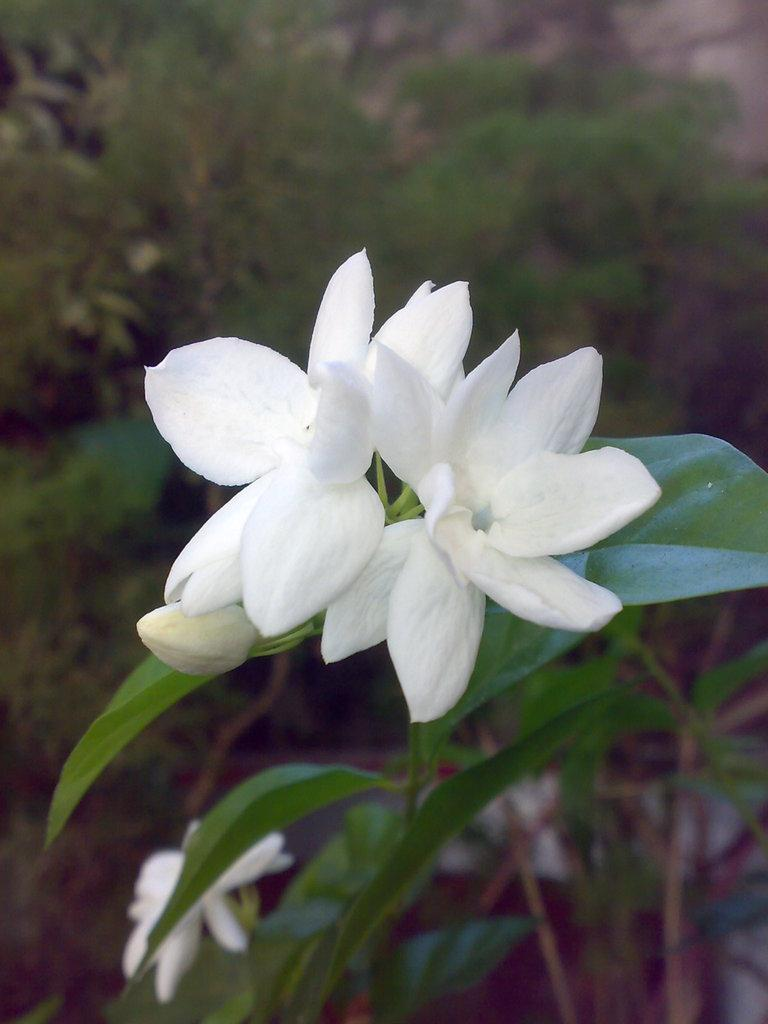What is the focus of the image? The image is zoomed in on plants. What type of plants are in the center of the image? There are plants with white color flowers in the center of the image. What can be seen in the background of the image? There is grass and more plants in the background of the image. What type of vegetable is being held in a pin in the image? There is no vegetable or pin present in the image; it features plants with white flowers. 